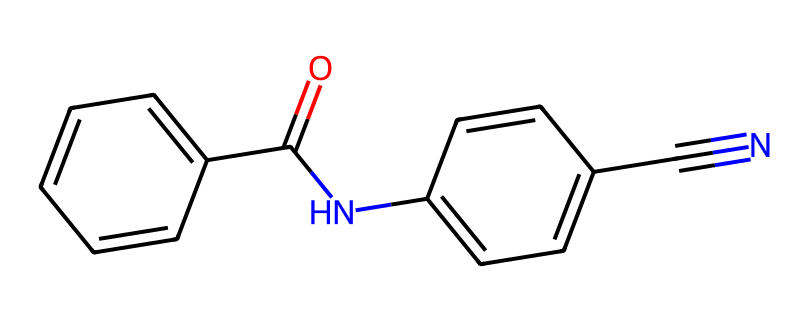What is the total number of carbon atoms in this compound? By examining the SMILES notation, we see the presence of 13 carbon atoms, both in the aromatic rings and the side groups. Each 'c' in the SMILES represents a carbon atom, and we count them directly.
Answer: 13 How many nitrogen atoms are present in this compound? In the SMILES notation, there are two 'N' letters indicating two nitrogen atoms in the structure. This is counted directly from the representation.
Answer: 2 What is the functional group represented by the 'C(=O)N' part of this chemical? The 'C(=O)N' indicates a carbonyl (C=O) adjacent to a nitrogen atom, forming an amide group. This can be identified due to the presence of the carbonyl carbon connected to a nitrogen.
Answer: amide Does this structure contain any triple bonds? In the given SMILES representation, the presence of '#N' indicates a triple bond between carbon and nitrogen, confirming that there is indeed a triple bond in the compound.
Answer: Yes What type of compounds are represented in the structure based on their rings? The presence of alternating double bonds within the rings (as seen in the 'c' pattern) indicates that this is an aromatic compound due to its stable electron configuration and resonance.
Answer: Aromatic Which functional group contributes to the compound’s potential reactivity in high-performance sports equipment? The presence of the cyano group represented by 'C#N' contributes to the compound's potential reactivity, as this group can participate in various chemical reactions that enhance material properties.
Answer: Cyano group 